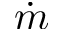Convert formula to latex. <formula><loc_0><loc_0><loc_500><loc_500>\dot { m }</formula> 